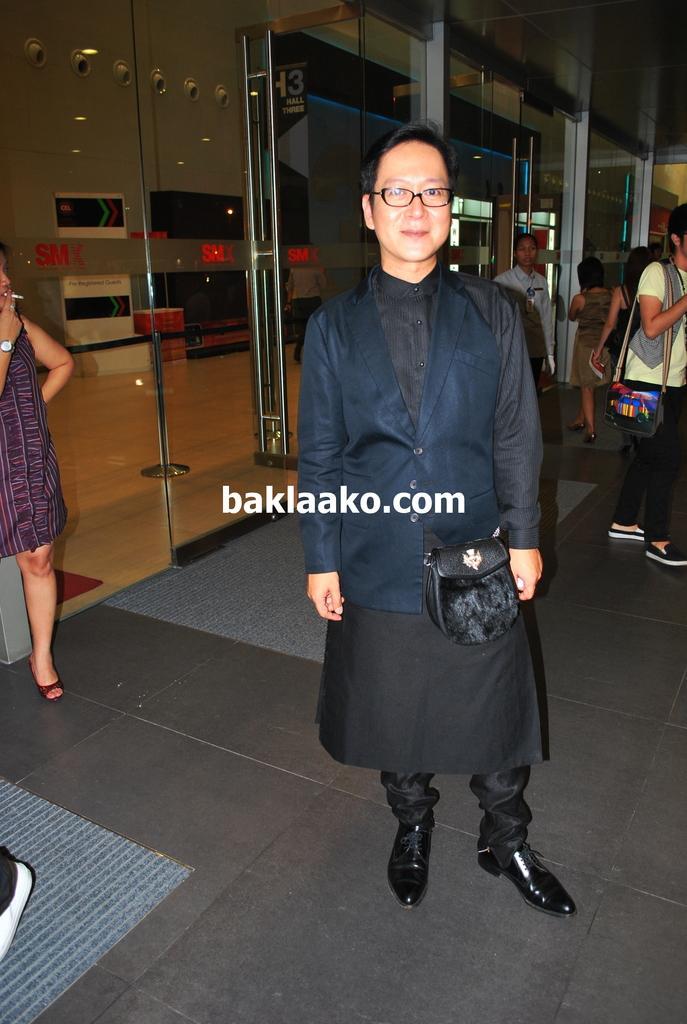How would you summarize this image in a sentence or two? In the foreground of this image, there is a man standing, carrying a bag. In the background, there are few people walking on the floor and also a glass wall through which, we can see few screen like objects, posters and the wall. On the left, there is a woman, standing and smoking. 